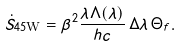<formula> <loc_0><loc_0><loc_500><loc_500>\dot { S } _ { 4 5 \text {W} } = \beta ^ { 2 } \frac { \lambda \Lambda ( \lambda ) } { h c } \, \Delta \lambda \, \Theta _ { f } .</formula> 